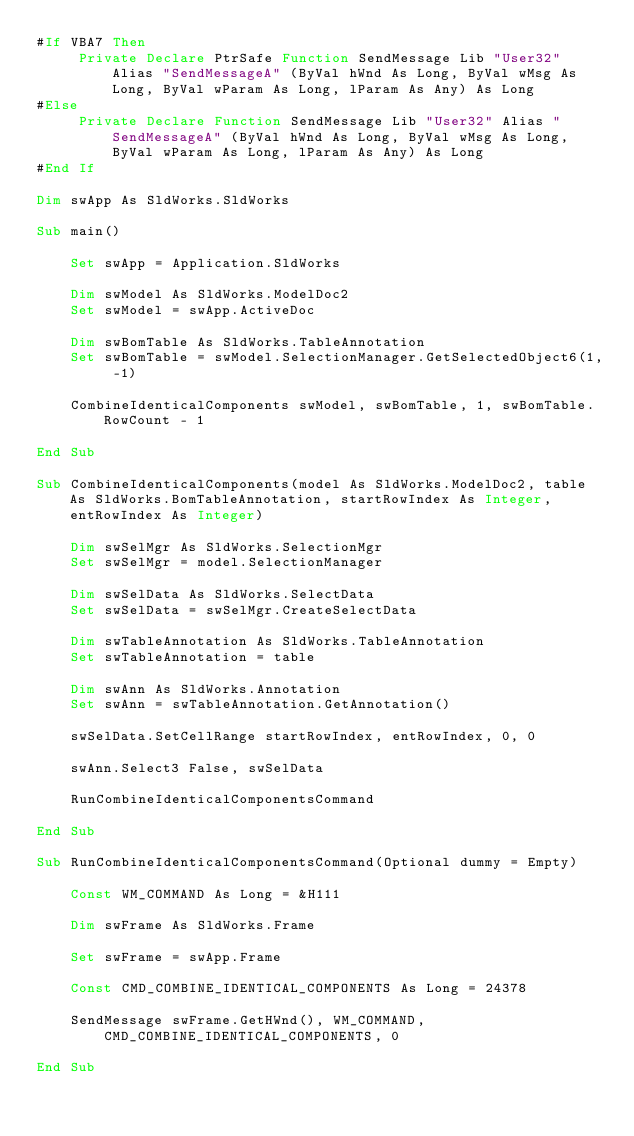<code> <loc_0><loc_0><loc_500><loc_500><_VisualBasic_>#If VBA7 Then
     Private Declare PtrSafe Function SendMessage Lib "User32" Alias "SendMessageA" (ByVal hWnd As Long, ByVal wMsg As Long, ByVal wParam As Long, lParam As Any) As Long
#Else
     Private Declare Function SendMessage Lib "User32" Alias "SendMessageA" (ByVal hWnd As Long, ByVal wMsg As Long, ByVal wParam As Long, lParam As Any) As Long
#End If

Dim swApp As SldWorks.SldWorks

Sub main()

    Set swApp = Application.SldWorks

    Dim swModel As SldWorks.ModelDoc2
    Set swModel = swApp.ActiveDoc
    
    Dim swBomTable As SldWorks.TableAnnotation
    Set swBomTable = swModel.SelectionManager.GetSelectedObject6(1, -1)
    
    CombineIdenticalComponents swModel, swBomTable, 1, swBomTable.RowCount - 1
    
End Sub

Sub CombineIdenticalComponents(model As SldWorks.ModelDoc2, table As SldWorks.BomTableAnnotation, startRowIndex As Integer, entRowIndex As Integer)
    
    Dim swSelMgr As SldWorks.SelectionMgr
    Set swSelMgr = model.SelectionManager
    
    Dim swSelData As SldWorks.SelectData
    Set swSelData = swSelMgr.CreateSelectData
    
    Dim swTableAnnotation As SldWorks.TableAnnotation
    Set swTableAnnotation = table
    
    Dim swAnn As SldWorks.Annotation
    Set swAnn = swTableAnnotation.GetAnnotation()
    
    swSelData.SetCellRange startRowIndex, entRowIndex, 0, 0
    
    swAnn.Select3 False, swSelData
    
    RunCombineIdenticalComponentsCommand
    
End Sub

Sub RunCombineIdenticalComponentsCommand(Optional dummy = Empty)
    
    Const WM_COMMAND As Long = &H111
        
    Dim swFrame As SldWorks.Frame
        
    Set swFrame = swApp.Frame
        
    Const CMD_COMBINE_IDENTICAL_COMPONENTS As Long = 24378
        
    SendMessage swFrame.GetHWnd(), WM_COMMAND, CMD_COMBINE_IDENTICAL_COMPONENTS, 0
    
End Sub</code> 